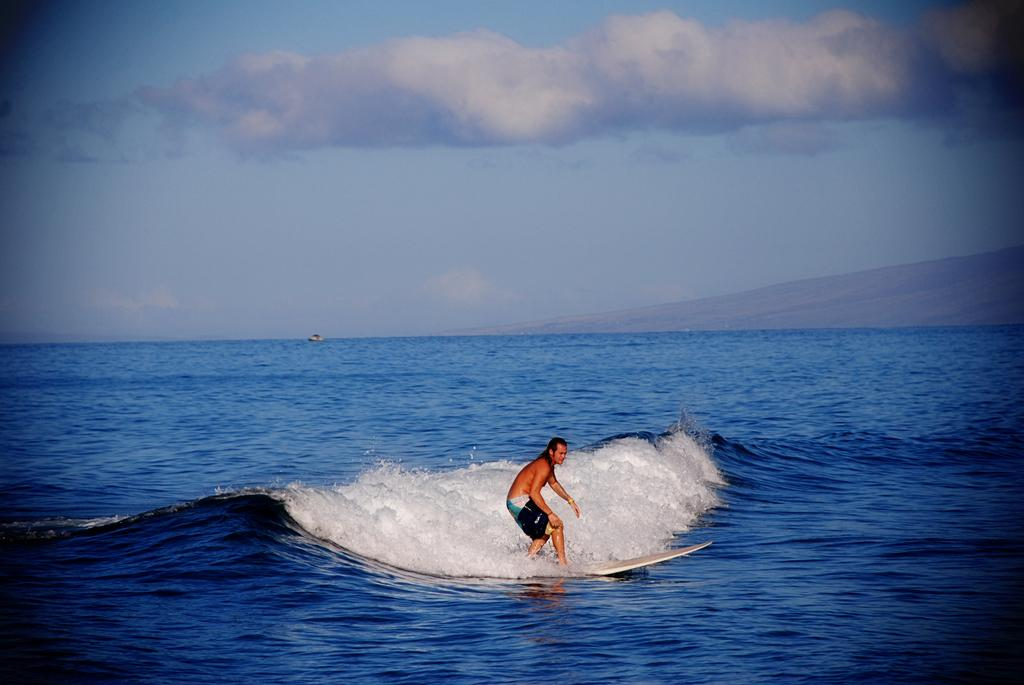Who is the main subject in the image? There is a man in the image. What is the man doing in the image? The man is standing on a surfboard and surfing on the water. What can be seen in the background of the image? There is sky visible in the background of the image. What is the condition of the sky in the image? Clouds are present in the sky. Can you see any tubs or bees in the image? No, there are no tubs or bees present in the image. Is there a zoo visible in the background of the image? No, there is no zoo visible in the image; only the sky and clouds can be seen in the background. 